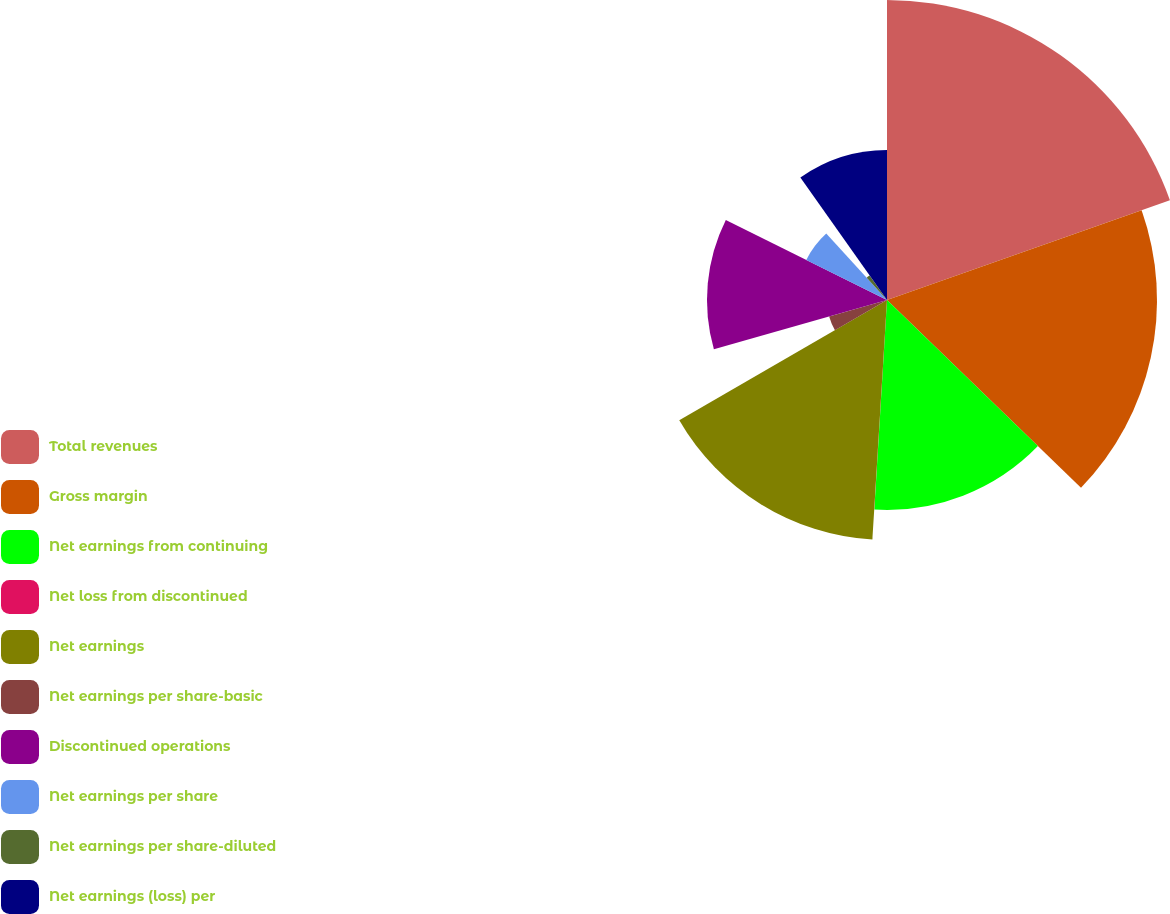<chart> <loc_0><loc_0><loc_500><loc_500><pie_chart><fcel>Total revenues<fcel>Gross margin<fcel>Net earnings from continuing<fcel>Net loss from discontinued<fcel>Net earnings<fcel>Net earnings per share-basic<fcel>Discontinued operations<fcel>Net earnings per share<fcel>Net earnings per share-diluted<fcel>Net earnings (loss) per<nl><fcel>19.6%<fcel>17.64%<fcel>13.72%<fcel>0.01%<fcel>15.68%<fcel>3.93%<fcel>11.76%<fcel>5.89%<fcel>1.97%<fcel>9.8%<nl></chart> 